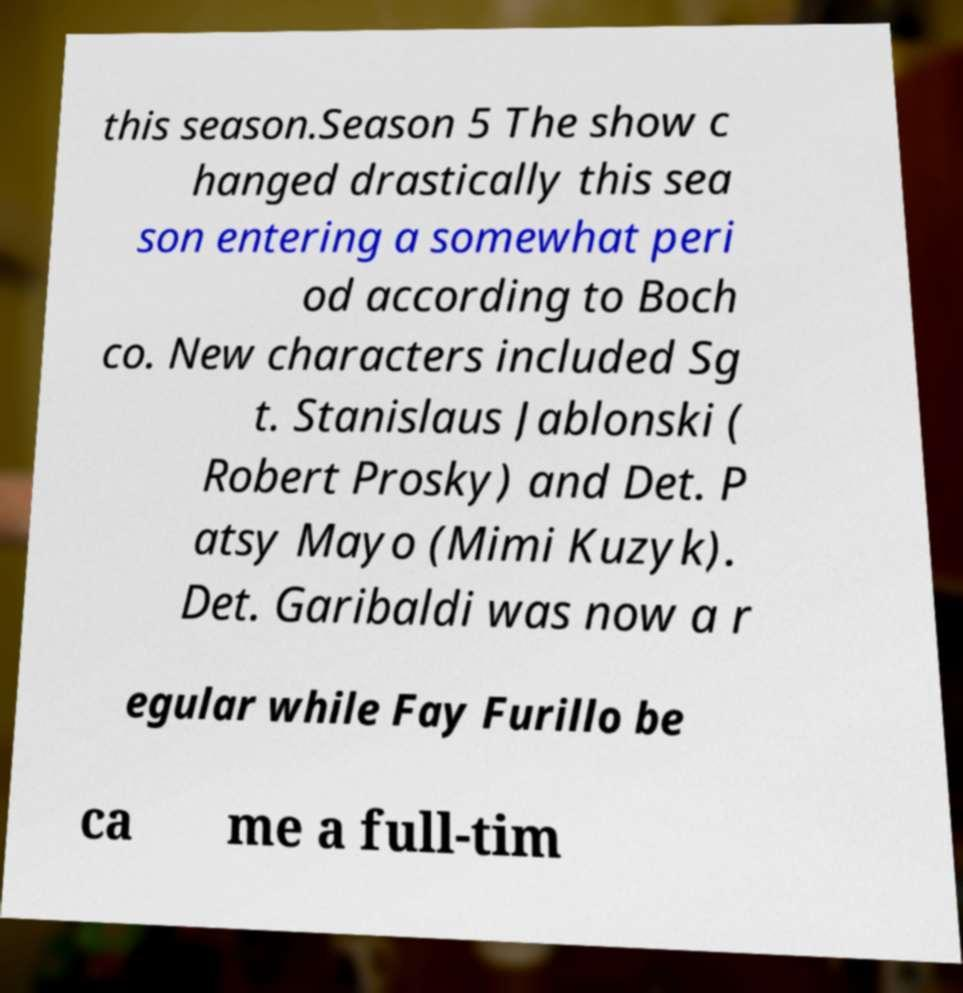Can you accurately transcribe the text from the provided image for me? this season.Season 5 The show c hanged drastically this sea son entering a somewhat peri od according to Boch co. New characters included Sg t. Stanislaus Jablonski ( Robert Prosky) and Det. P atsy Mayo (Mimi Kuzyk). Det. Garibaldi was now a r egular while Fay Furillo be ca me a full-tim 